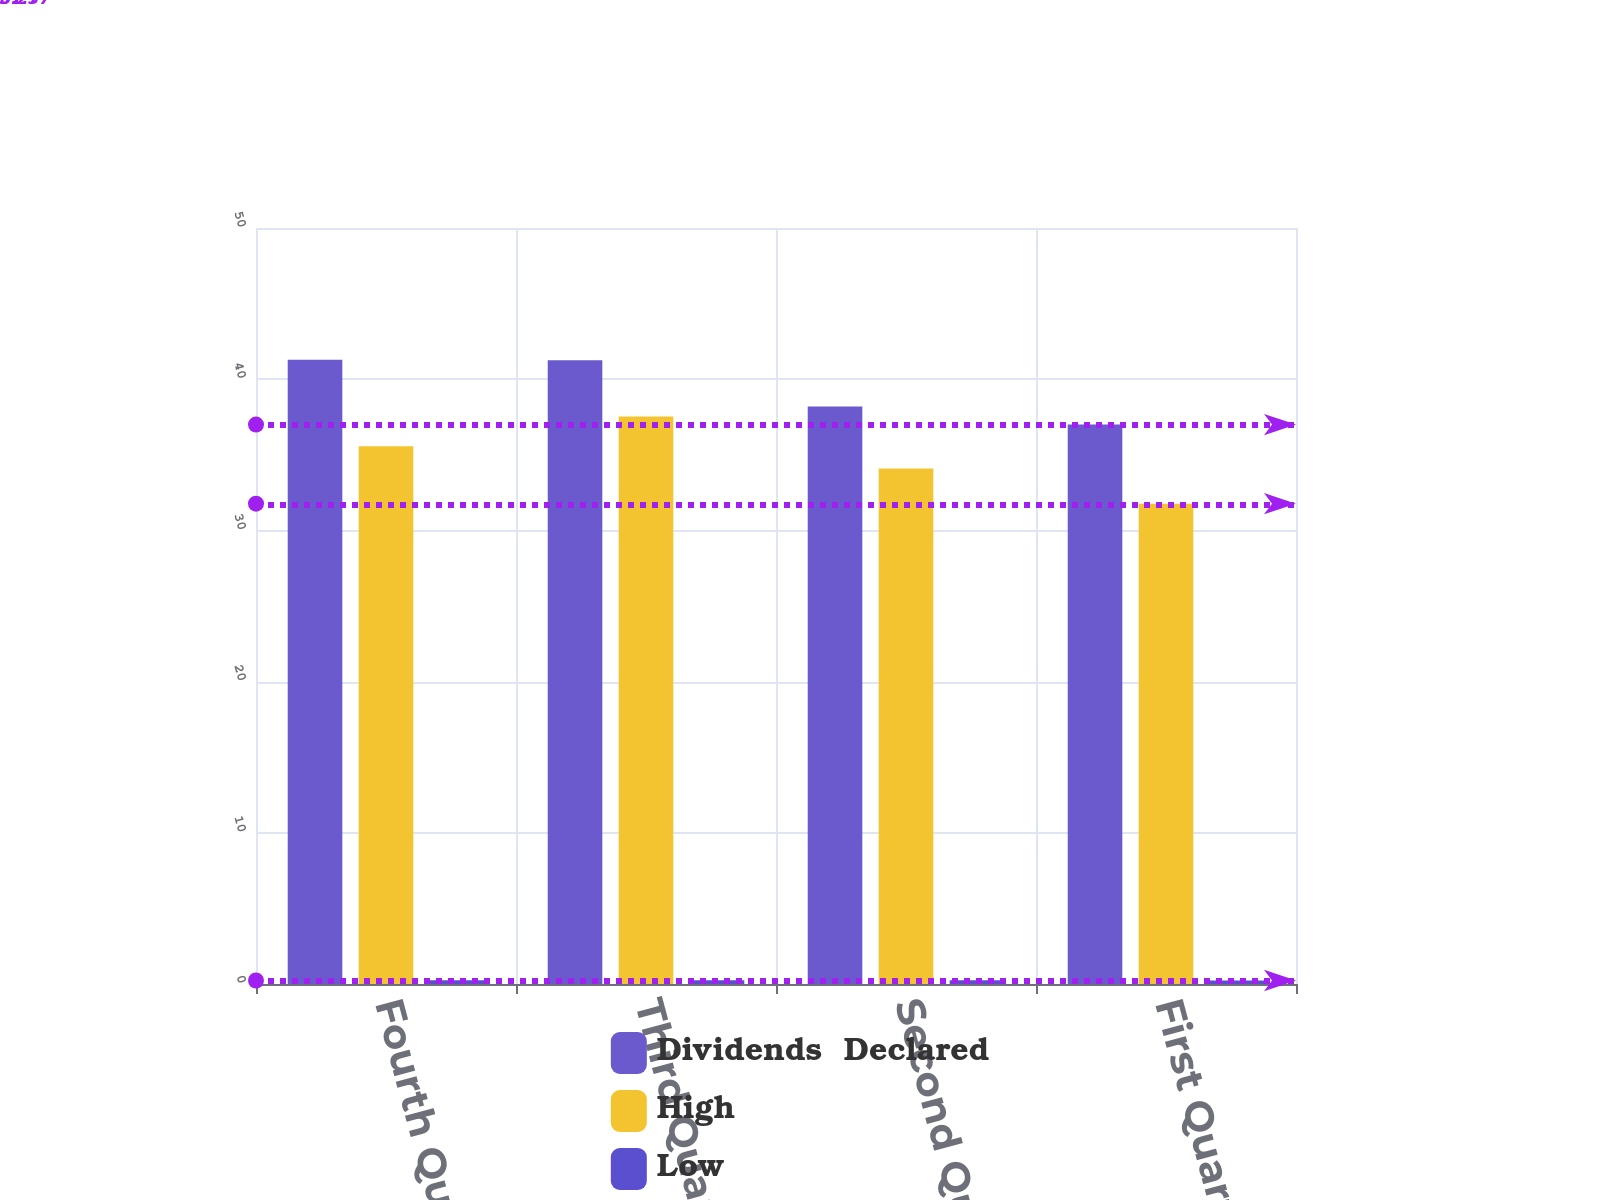<chart> <loc_0><loc_0><loc_500><loc_500><stacked_bar_chart><ecel><fcel>Fourth Quarter<fcel>Third Quarter<fcel>Second Quarter<fcel>First Quarter<nl><fcel>Dividends  Declared<fcel>41.28<fcel>41.25<fcel>38.2<fcel>37<nl><fcel>High<fcel>35.56<fcel>37.54<fcel>34.09<fcel>31.77<nl><fcel>Low<fcel>0.25<fcel>0.25<fcel>0.25<fcel>0.23<nl></chart> 